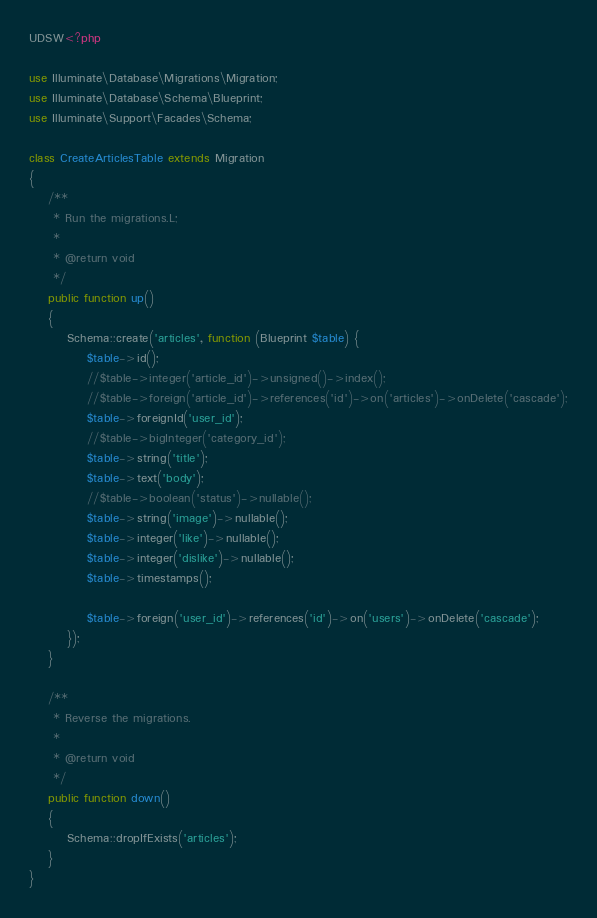Convert code to text. <code><loc_0><loc_0><loc_500><loc_500><_PHP_>UDSW<?php

use Illuminate\Database\Migrations\Migration;
use Illuminate\Database\Schema\Blueprint;
use Illuminate\Support\Facades\Schema;

class CreateArticlesTable extends Migration
{
    /**
     * Run the migrations.L;
     *
     * @return void
     */
    public function up()
    {
        Schema::create('articles', function (Blueprint $table) {
            $table->id();
            //$table->integer('article_id')->unsigned()->index();
            //$table->foreign('article_id')->references('id')->on('articles')->onDelete('cascade');
            $table->foreignId('user_id');
            //$table->bigInteger('category_id');
            $table->string('title');
            $table->text('body');
            //$table->boolean('status')->nullable();
            $table->string('image')->nullable();
            $table->integer('like')->nullable();
            $table->integer('dislike')->nullable();
            $table->timestamps();

            $table->foreign('user_id')->references('id')->on('users')->onDelete('cascade');
        });
    }

    /**
     * Reverse the migrations.
     *
     * @return void
     */
    public function down()
    {
        Schema::dropIfExists('articles');
    }
}
</code> 